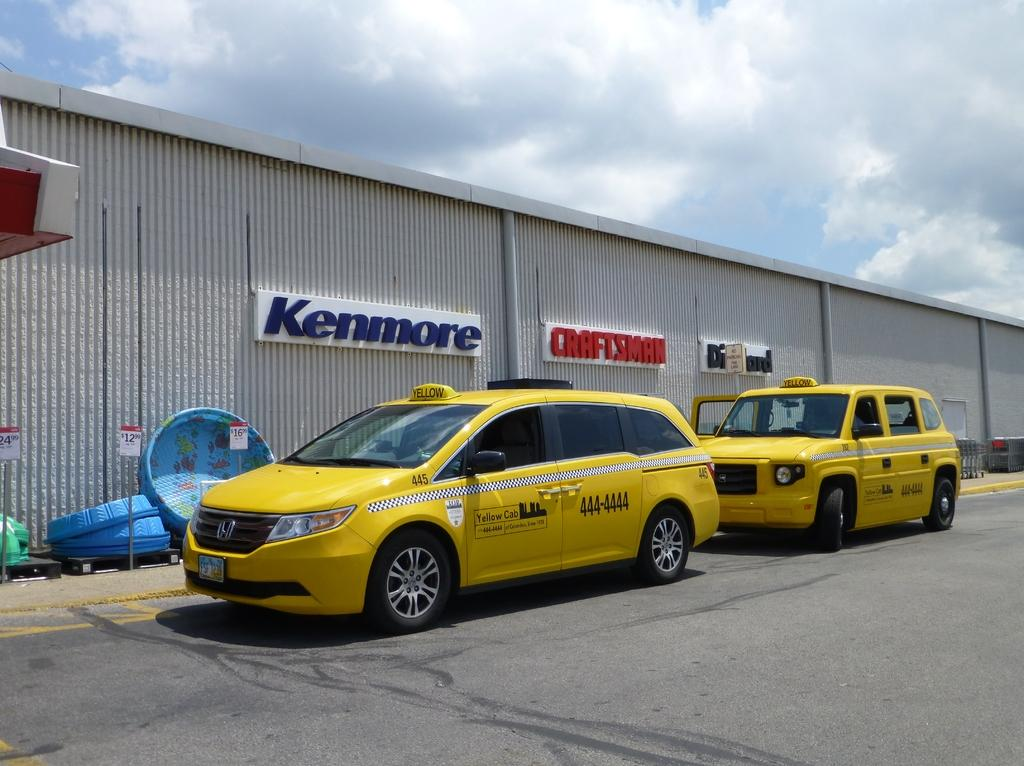<image>
Summarize the visual content of the image. A picture of a taxi sitting in front of a Kenmore sign 